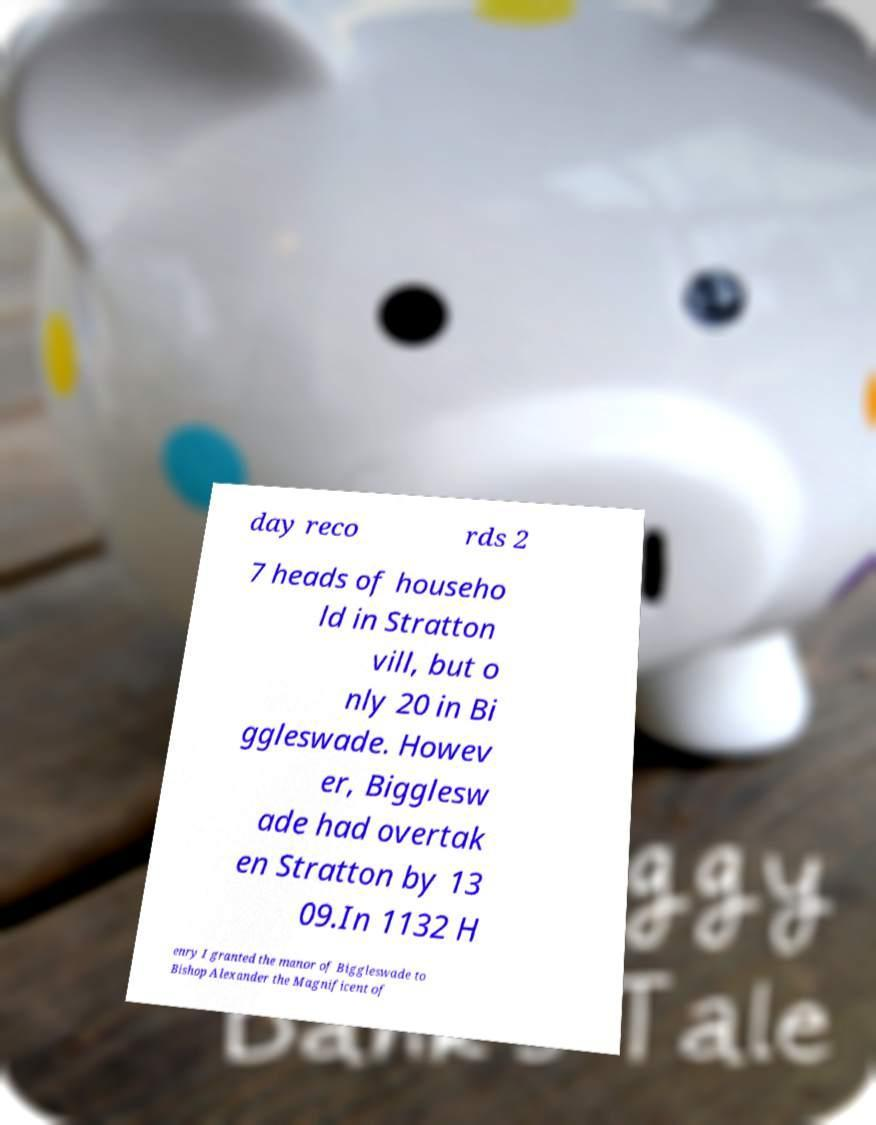Please identify and transcribe the text found in this image. day reco rds 2 7 heads of househo ld in Stratton vill, but o nly 20 in Bi ggleswade. Howev er, Bigglesw ade had overtak en Stratton by 13 09.In 1132 H enry I granted the manor of Biggleswade to Bishop Alexander the Magnificent of 